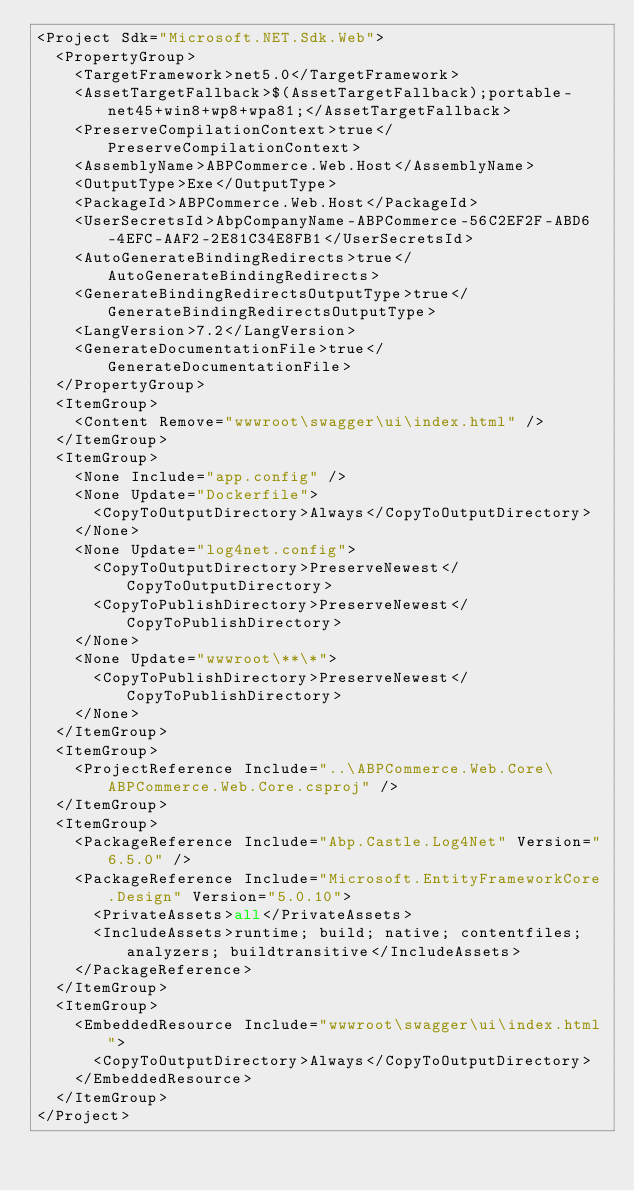Convert code to text. <code><loc_0><loc_0><loc_500><loc_500><_XML_><Project Sdk="Microsoft.NET.Sdk.Web">
  <PropertyGroup>
    <TargetFramework>net5.0</TargetFramework>
    <AssetTargetFallback>$(AssetTargetFallback);portable-net45+win8+wp8+wpa81;</AssetTargetFallback>
    <PreserveCompilationContext>true</PreserveCompilationContext>
    <AssemblyName>ABPCommerce.Web.Host</AssemblyName>
    <OutputType>Exe</OutputType>
    <PackageId>ABPCommerce.Web.Host</PackageId>
    <UserSecretsId>AbpCompanyName-ABPCommerce-56C2EF2F-ABD6-4EFC-AAF2-2E81C34E8FB1</UserSecretsId>
    <AutoGenerateBindingRedirects>true</AutoGenerateBindingRedirects>
    <GenerateBindingRedirectsOutputType>true</GenerateBindingRedirectsOutputType>
    <LangVersion>7.2</LangVersion>
    <GenerateDocumentationFile>true</GenerateDocumentationFile>
  </PropertyGroup>
  <ItemGroup>
    <Content Remove="wwwroot\swagger\ui\index.html" />
  </ItemGroup>
  <ItemGroup>
    <None Include="app.config" />
    <None Update="Dockerfile">
      <CopyToOutputDirectory>Always</CopyToOutputDirectory>
    </None>
    <None Update="log4net.config">
      <CopyToOutputDirectory>PreserveNewest</CopyToOutputDirectory>
      <CopyToPublishDirectory>PreserveNewest</CopyToPublishDirectory>
    </None>
    <None Update="wwwroot\**\*">
      <CopyToPublishDirectory>PreserveNewest</CopyToPublishDirectory>
    </None>
  </ItemGroup>
  <ItemGroup>
    <ProjectReference Include="..\ABPCommerce.Web.Core\ABPCommerce.Web.Core.csproj" />
  </ItemGroup>
  <ItemGroup>
    <PackageReference Include="Abp.Castle.Log4Net" Version="6.5.0" />
    <PackageReference Include="Microsoft.EntityFrameworkCore.Design" Version="5.0.10">
      <PrivateAssets>all</PrivateAssets>
      <IncludeAssets>runtime; build; native; contentfiles; analyzers; buildtransitive</IncludeAssets>
    </PackageReference>
  </ItemGroup>
  <ItemGroup>
    <EmbeddedResource Include="wwwroot\swagger\ui\index.html">
      <CopyToOutputDirectory>Always</CopyToOutputDirectory>
    </EmbeddedResource>
  </ItemGroup>
</Project></code> 